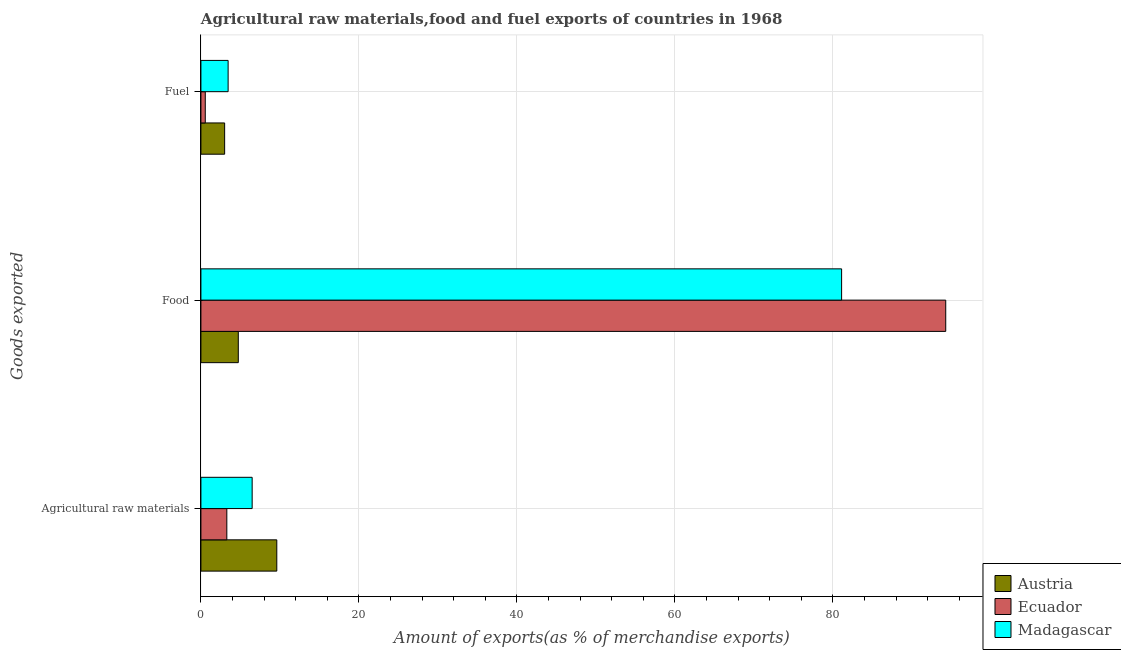How many different coloured bars are there?
Offer a very short reply. 3. Are the number of bars on each tick of the Y-axis equal?
Your response must be concise. Yes. What is the label of the 2nd group of bars from the top?
Your answer should be very brief. Food. What is the percentage of fuel exports in Madagascar?
Offer a very short reply. 3.44. Across all countries, what is the maximum percentage of food exports?
Keep it short and to the point. 94.29. Across all countries, what is the minimum percentage of fuel exports?
Give a very brief answer. 0.55. In which country was the percentage of food exports maximum?
Provide a succinct answer. Ecuador. In which country was the percentage of fuel exports minimum?
Your response must be concise. Ecuador. What is the total percentage of fuel exports in the graph?
Provide a succinct answer. 7. What is the difference between the percentage of food exports in Ecuador and that in Madagascar?
Give a very brief answer. 13.18. What is the difference between the percentage of raw materials exports in Madagascar and the percentage of food exports in Austria?
Offer a very short reply. 1.75. What is the average percentage of raw materials exports per country?
Give a very brief answer. 6.46. What is the difference between the percentage of food exports and percentage of fuel exports in Madagascar?
Provide a short and direct response. 77.66. What is the ratio of the percentage of food exports in Madagascar to that in Austria?
Offer a very short reply. 17.14. Is the difference between the percentage of food exports in Madagascar and Austria greater than the difference between the percentage of fuel exports in Madagascar and Austria?
Your answer should be compact. Yes. What is the difference between the highest and the second highest percentage of fuel exports?
Your response must be concise. 0.44. What is the difference between the highest and the lowest percentage of fuel exports?
Provide a succinct answer. 2.89. In how many countries, is the percentage of food exports greater than the average percentage of food exports taken over all countries?
Provide a short and direct response. 2. What does the 1st bar from the top in Food represents?
Ensure brevity in your answer.  Madagascar. What does the 3rd bar from the bottom in Fuel represents?
Provide a short and direct response. Madagascar. Is it the case that in every country, the sum of the percentage of raw materials exports and percentage of food exports is greater than the percentage of fuel exports?
Your answer should be very brief. Yes. Are all the bars in the graph horizontal?
Provide a succinct answer. Yes. What is the difference between two consecutive major ticks on the X-axis?
Give a very brief answer. 20. Does the graph contain any zero values?
Your answer should be compact. No. Does the graph contain grids?
Make the answer very short. Yes. Where does the legend appear in the graph?
Provide a succinct answer. Bottom right. What is the title of the graph?
Keep it short and to the point. Agricultural raw materials,food and fuel exports of countries in 1968. Does "OECD members" appear as one of the legend labels in the graph?
Your answer should be very brief. No. What is the label or title of the X-axis?
Offer a very short reply. Amount of exports(as % of merchandise exports). What is the label or title of the Y-axis?
Your response must be concise. Goods exported. What is the Amount of exports(as % of merchandise exports) in Austria in Agricultural raw materials?
Ensure brevity in your answer.  9.61. What is the Amount of exports(as % of merchandise exports) in Ecuador in Agricultural raw materials?
Offer a terse response. 3.28. What is the Amount of exports(as % of merchandise exports) of Madagascar in Agricultural raw materials?
Your answer should be very brief. 6.49. What is the Amount of exports(as % of merchandise exports) in Austria in Food?
Offer a terse response. 4.73. What is the Amount of exports(as % of merchandise exports) in Ecuador in Food?
Provide a succinct answer. 94.29. What is the Amount of exports(as % of merchandise exports) of Madagascar in Food?
Provide a succinct answer. 81.1. What is the Amount of exports(as % of merchandise exports) in Austria in Fuel?
Ensure brevity in your answer.  3. What is the Amount of exports(as % of merchandise exports) of Ecuador in Fuel?
Make the answer very short. 0.55. What is the Amount of exports(as % of merchandise exports) of Madagascar in Fuel?
Provide a short and direct response. 3.44. Across all Goods exported, what is the maximum Amount of exports(as % of merchandise exports) in Austria?
Offer a very short reply. 9.61. Across all Goods exported, what is the maximum Amount of exports(as % of merchandise exports) of Ecuador?
Offer a very short reply. 94.29. Across all Goods exported, what is the maximum Amount of exports(as % of merchandise exports) in Madagascar?
Offer a very short reply. 81.1. Across all Goods exported, what is the minimum Amount of exports(as % of merchandise exports) of Austria?
Your answer should be very brief. 3. Across all Goods exported, what is the minimum Amount of exports(as % of merchandise exports) in Ecuador?
Ensure brevity in your answer.  0.55. Across all Goods exported, what is the minimum Amount of exports(as % of merchandise exports) in Madagascar?
Make the answer very short. 3.44. What is the total Amount of exports(as % of merchandise exports) of Austria in the graph?
Offer a very short reply. 17.34. What is the total Amount of exports(as % of merchandise exports) of Ecuador in the graph?
Provide a short and direct response. 98.12. What is the total Amount of exports(as % of merchandise exports) of Madagascar in the graph?
Ensure brevity in your answer.  91.03. What is the difference between the Amount of exports(as % of merchandise exports) of Austria in Agricultural raw materials and that in Food?
Your answer should be compact. 4.87. What is the difference between the Amount of exports(as % of merchandise exports) in Ecuador in Agricultural raw materials and that in Food?
Your answer should be compact. -91. What is the difference between the Amount of exports(as % of merchandise exports) in Madagascar in Agricultural raw materials and that in Food?
Offer a terse response. -74.62. What is the difference between the Amount of exports(as % of merchandise exports) in Austria in Agricultural raw materials and that in Fuel?
Your answer should be very brief. 6.6. What is the difference between the Amount of exports(as % of merchandise exports) in Ecuador in Agricultural raw materials and that in Fuel?
Offer a very short reply. 2.73. What is the difference between the Amount of exports(as % of merchandise exports) of Madagascar in Agricultural raw materials and that in Fuel?
Ensure brevity in your answer.  3.04. What is the difference between the Amount of exports(as % of merchandise exports) in Austria in Food and that in Fuel?
Your answer should be compact. 1.73. What is the difference between the Amount of exports(as % of merchandise exports) in Ecuador in Food and that in Fuel?
Ensure brevity in your answer.  93.73. What is the difference between the Amount of exports(as % of merchandise exports) in Madagascar in Food and that in Fuel?
Your answer should be very brief. 77.66. What is the difference between the Amount of exports(as % of merchandise exports) of Austria in Agricultural raw materials and the Amount of exports(as % of merchandise exports) of Ecuador in Food?
Your response must be concise. -84.68. What is the difference between the Amount of exports(as % of merchandise exports) of Austria in Agricultural raw materials and the Amount of exports(as % of merchandise exports) of Madagascar in Food?
Your response must be concise. -71.5. What is the difference between the Amount of exports(as % of merchandise exports) in Ecuador in Agricultural raw materials and the Amount of exports(as % of merchandise exports) in Madagascar in Food?
Give a very brief answer. -77.82. What is the difference between the Amount of exports(as % of merchandise exports) in Austria in Agricultural raw materials and the Amount of exports(as % of merchandise exports) in Ecuador in Fuel?
Provide a short and direct response. 9.05. What is the difference between the Amount of exports(as % of merchandise exports) of Austria in Agricultural raw materials and the Amount of exports(as % of merchandise exports) of Madagascar in Fuel?
Give a very brief answer. 6.16. What is the difference between the Amount of exports(as % of merchandise exports) in Ecuador in Agricultural raw materials and the Amount of exports(as % of merchandise exports) in Madagascar in Fuel?
Ensure brevity in your answer.  -0.16. What is the difference between the Amount of exports(as % of merchandise exports) of Austria in Food and the Amount of exports(as % of merchandise exports) of Ecuador in Fuel?
Your answer should be very brief. 4.18. What is the difference between the Amount of exports(as % of merchandise exports) of Austria in Food and the Amount of exports(as % of merchandise exports) of Madagascar in Fuel?
Make the answer very short. 1.29. What is the difference between the Amount of exports(as % of merchandise exports) of Ecuador in Food and the Amount of exports(as % of merchandise exports) of Madagascar in Fuel?
Your response must be concise. 90.84. What is the average Amount of exports(as % of merchandise exports) of Austria per Goods exported?
Offer a terse response. 5.78. What is the average Amount of exports(as % of merchandise exports) of Ecuador per Goods exported?
Your answer should be compact. 32.71. What is the average Amount of exports(as % of merchandise exports) of Madagascar per Goods exported?
Ensure brevity in your answer.  30.34. What is the difference between the Amount of exports(as % of merchandise exports) of Austria and Amount of exports(as % of merchandise exports) of Ecuador in Agricultural raw materials?
Give a very brief answer. 6.33. What is the difference between the Amount of exports(as % of merchandise exports) in Austria and Amount of exports(as % of merchandise exports) in Madagascar in Agricultural raw materials?
Offer a terse response. 3.12. What is the difference between the Amount of exports(as % of merchandise exports) of Ecuador and Amount of exports(as % of merchandise exports) of Madagascar in Agricultural raw materials?
Provide a succinct answer. -3.21. What is the difference between the Amount of exports(as % of merchandise exports) of Austria and Amount of exports(as % of merchandise exports) of Ecuador in Food?
Your answer should be very brief. -89.55. What is the difference between the Amount of exports(as % of merchandise exports) in Austria and Amount of exports(as % of merchandise exports) in Madagascar in Food?
Your answer should be compact. -76.37. What is the difference between the Amount of exports(as % of merchandise exports) in Ecuador and Amount of exports(as % of merchandise exports) in Madagascar in Food?
Offer a terse response. 13.18. What is the difference between the Amount of exports(as % of merchandise exports) in Austria and Amount of exports(as % of merchandise exports) in Ecuador in Fuel?
Provide a succinct answer. 2.45. What is the difference between the Amount of exports(as % of merchandise exports) in Austria and Amount of exports(as % of merchandise exports) in Madagascar in Fuel?
Give a very brief answer. -0.44. What is the difference between the Amount of exports(as % of merchandise exports) in Ecuador and Amount of exports(as % of merchandise exports) in Madagascar in Fuel?
Offer a terse response. -2.89. What is the ratio of the Amount of exports(as % of merchandise exports) in Austria in Agricultural raw materials to that in Food?
Offer a terse response. 2.03. What is the ratio of the Amount of exports(as % of merchandise exports) of Ecuador in Agricultural raw materials to that in Food?
Your response must be concise. 0.03. What is the ratio of the Amount of exports(as % of merchandise exports) of Madagascar in Agricultural raw materials to that in Food?
Give a very brief answer. 0.08. What is the ratio of the Amount of exports(as % of merchandise exports) of Austria in Agricultural raw materials to that in Fuel?
Offer a very short reply. 3.2. What is the ratio of the Amount of exports(as % of merchandise exports) of Ecuador in Agricultural raw materials to that in Fuel?
Your response must be concise. 5.94. What is the ratio of the Amount of exports(as % of merchandise exports) of Madagascar in Agricultural raw materials to that in Fuel?
Offer a very short reply. 1.88. What is the ratio of the Amount of exports(as % of merchandise exports) in Austria in Food to that in Fuel?
Your answer should be very brief. 1.58. What is the ratio of the Amount of exports(as % of merchandise exports) in Ecuador in Food to that in Fuel?
Keep it short and to the point. 170.61. What is the ratio of the Amount of exports(as % of merchandise exports) in Madagascar in Food to that in Fuel?
Ensure brevity in your answer.  23.55. What is the difference between the highest and the second highest Amount of exports(as % of merchandise exports) of Austria?
Make the answer very short. 4.87. What is the difference between the highest and the second highest Amount of exports(as % of merchandise exports) of Ecuador?
Provide a short and direct response. 91. What is the difference between the highest and the second highest Amount of exports(as % of merchandise exports) in Madagascar?
Keep it short and to the point. 74.62. What is the difference between the highest and the lowest Amount of exports(as % of merchandise exports) in Austria?
Provide a succinct answer. 6.6. What is the difference between the highest and the lowest Amount of exports(as % of merchandise exports) of Ecuador?
Offer a terse response. 93.73. What is the difference between the highest and the lowest Amount of exports(as % of merchandise exports) of Madagascar?
Make the answer very short. 77.66. 